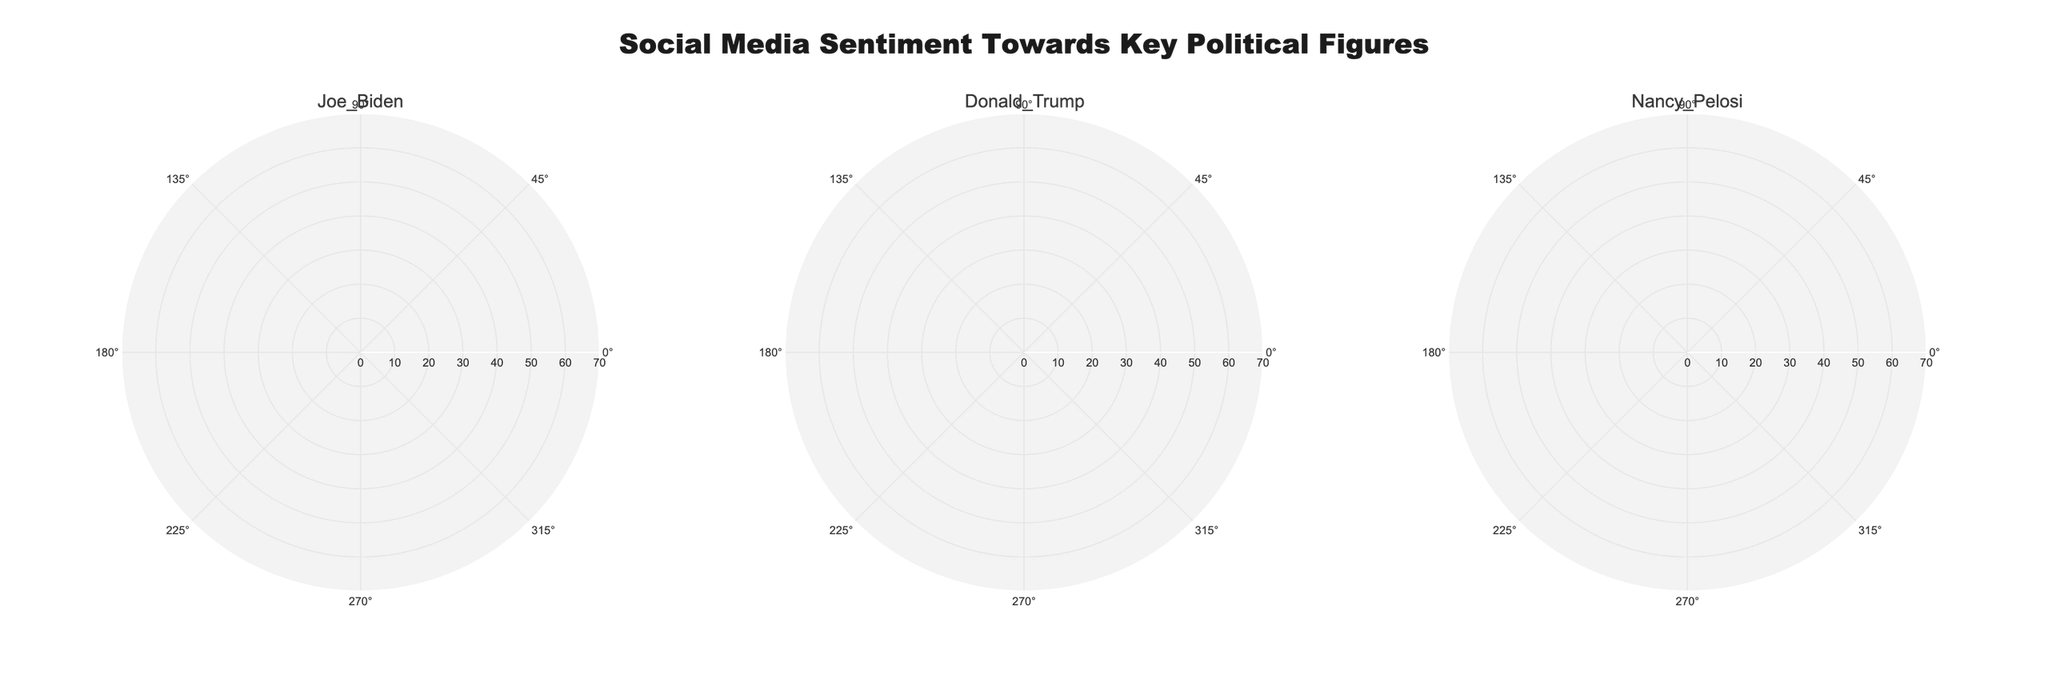Which political figure has the highest positive sentiment in August 2023? Look at the traces for August 2023 in each subplot and compare the positive sentiment values. Nancy Pelosi has the highest value.
Answer: Nancy Pelosi What is the general trend of sentiment towards Joe Biden from January to August 2023? Observe Joe Biden's subplot and note the changes in positive, neutral, and negative sentiment from January to August 2023. Positive sentiment fluctuates but ends higher than it started, while neutral and negative sentiments show minor variations.
Answer: Positive fluctuates, ends higher Compare the negative sentiment of Donald Trump and Nancy Pelosi in July 2023. Who faces more negative sentiment? Identify the negative sentiment values for both political figures in July 2023 by comparing the traces. Donald Trump has a higher negative sentiment.
Answer: Donald Trump What is the average positive sentiment towards Nancy Pelosi over the period shown? Calculate the average of the positive sentiments for Nancy Pelosi over the months. Sum the positive sentiments and divide by the number of months: (60+58+62+59+65+63+61+64)/8 = 61.5.
Answer: 61.5 Which month shows the highest negative sentiment towards Donald Trump? Review Donald Trump's subplot and check the negative sentiment for each month. July 2023 shows the highest value.
Answer: July 2023 Is there a month where Joe Biden's positive sentiment is the same as another political figure's positive sentiment? Compare Joe Biden's positive sentiment for each month with the other political figures'. Joe Biden and Nancy Pelosi both have a positive sentiment of 60 in March 2023.
Answer: March 2023 How does Nancy Pelosi's neutral sentiment change from February to August 2023? Determine the neutral sentiment for Nancy Pelosi in each month from February to August 2023. Notice the decrease from 25 in February to 16 in August.
Answer: Decreases Between April 2023 and July 2023, who shows a stronger improvement in positive sentiment: Joe Biden or Donald Trump? Compare the change in positive sentiment from April to July for both Joe Biden and Donald Trump. Joe Biden increases from 52 to 60, while Donald Trump decreases from 55 to 43. Joe Biden shows an improvement.
Answer: Joe Biden What is the range of neutral sentiment values observed for Joe Biden? Identify the minimum and maximum neutral sentiment values for Joe Biden. The range is from 20 to 25.
Answer: 20 to 25 Is there any political figure who has consistently higher positive sentiment compared to negative sentiment in each month? Examine each political figure's positive and negative sentiment values for all months. Nancy Pelosi consistently has higher positive sentiment than negative sentiment every month.
Answer: Nancy Pelosi 